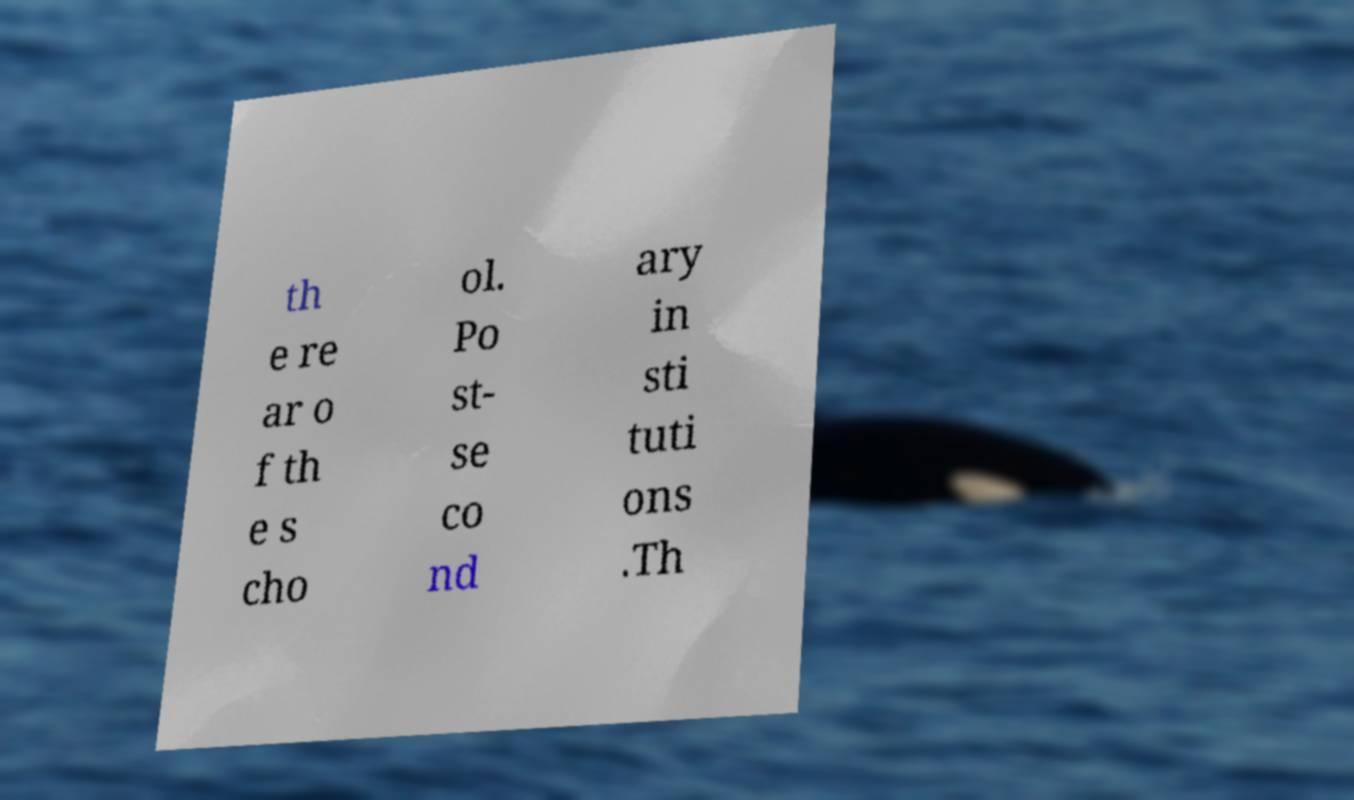For documentation purposes, I need the text within this image transcribed. Could you provide that? th e re ar o f th e s cho ol. Po st- se co nd ary in sti tuti ons .Th 